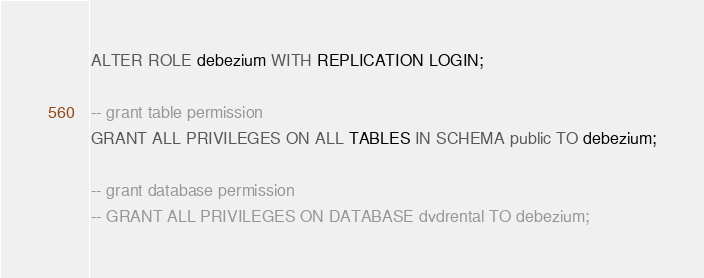<code> <loc_0><loc_0><loc_500><loc_500><_SQL_>ALTER ROLE debezium WITH REPLICATION LOGIN;

-- grant table permission
GRANT ALL PRIVILEGES ON ALL TABLES IN SCHEMA public TO debezium;

-- grant database permission
-- GRANT ALL PRIVILEGES ON DATABASE dvdrental TO debezium;
</code> 